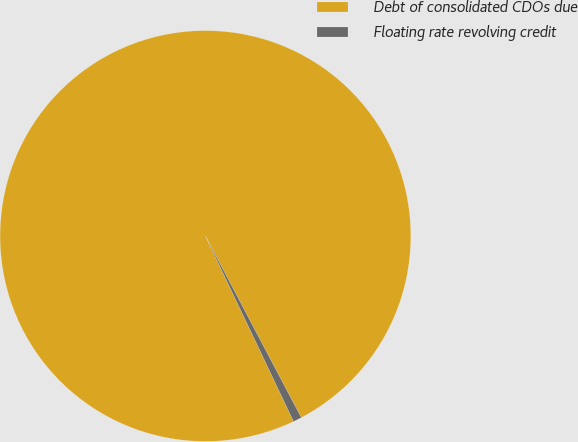Convert chart to OTSL. <chart><loc_0><loc_0><loc_500><loc_500><pie_chart><fcel>Debt of consolidated CDOs due<fcel>Floating rate revolving credit<nl><fcel>99.33%<fcel>0.67%<nl></chart> 